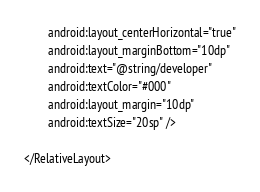Convert code to text. <code><loc_0><loc_0><loc_500><loc_500><_XML_>        android:layout_centerHorizontal="true"
        android:layout_marginBottom="10dp"
        android:text="@string/developer"
        android:textColor="#000"
        android:layout_margin="10dp"
        android:textSize="20sp" />

</RelativeLayout>
</code> 